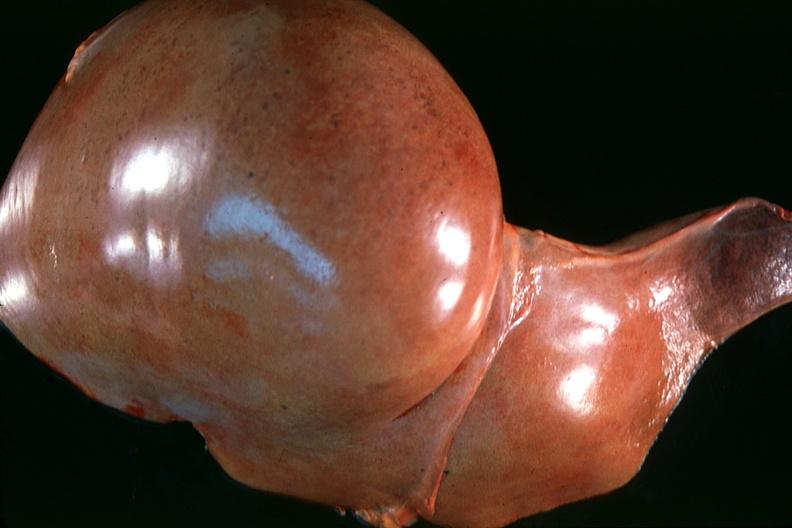does this image show normal liver?
Answer the question using a single word or phrase. Yes 